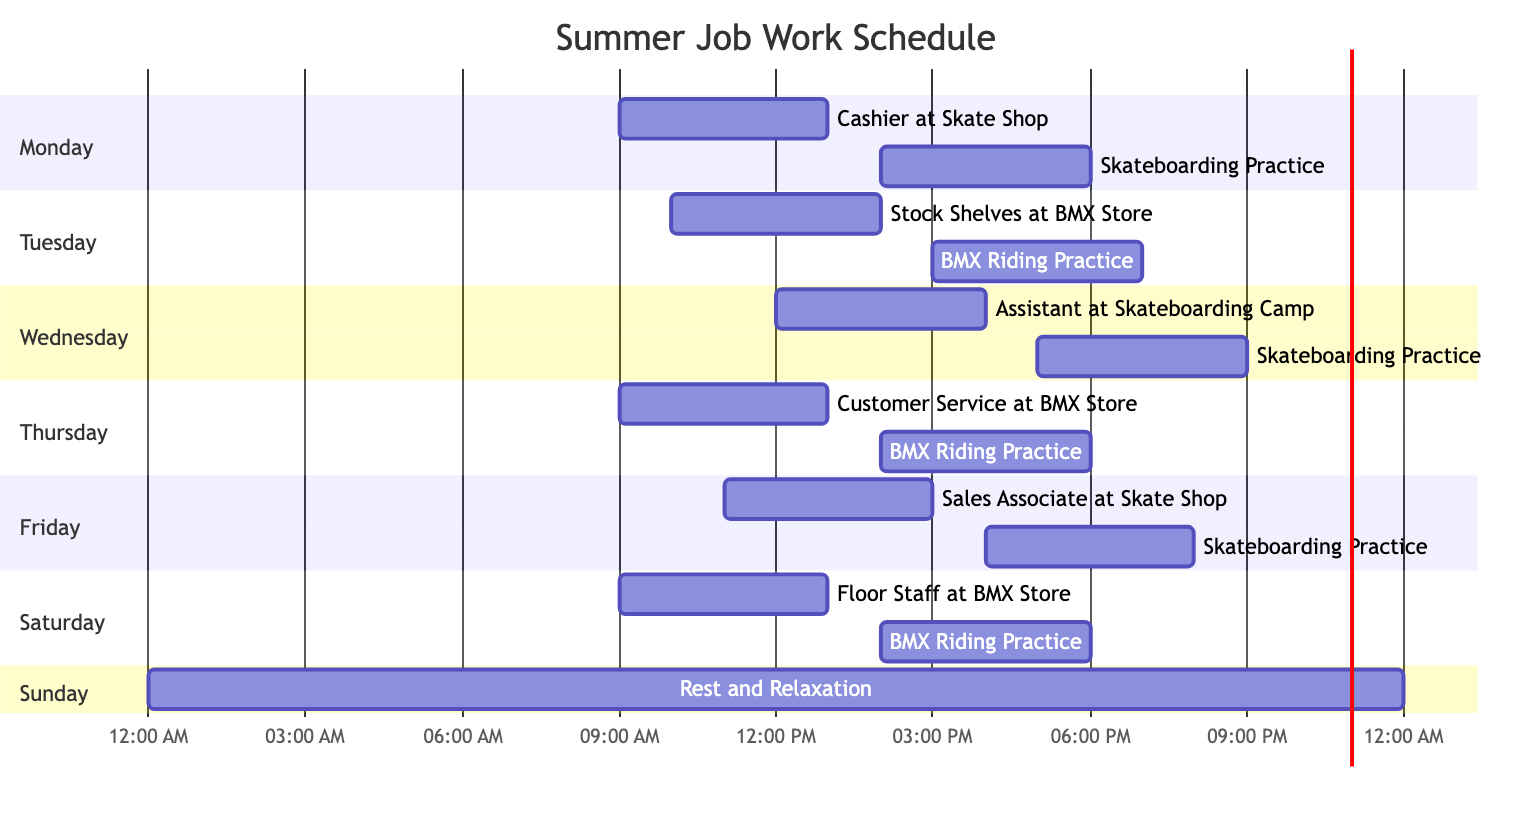What is the first activity on Monday? The diagram shows the schedule for Monday starting with the "Cashier at Skate Shop" shift scheduled at 09:00. This is the first activity listed under the Monday section.
Answer: Cashier at Skate Shop How many hours are dedicated to BMX Riding Practice? The schedule indicates BMX Riding Practice on Tuesday and Thursday for 4 hours each day, which totals to 8 hours across the week.
Answer: 8 hours What time does Skateboarding Practice start on Friday? The diagram indicates that Skateboarding Practice on Friday starts at 16:00, which is the scheduled start time listed under that day.
Answer: 16:00 Which day has a full 24-hour schedule for Rest and Relaxation? According to the diagram, Sunday is dedicated entirely to Rest and Relaxation, with a full 24-hour schedule indicated in that section.
Answer: Sunday On which day is the Assistant at Skateboarding Camp working? The schedule specifies that the Assistant at Skateboarding Camp works on Wednesday, starting at 12:00 for 4 hours. This is the only mention of this job in the entire diagram.
Answer: Wednesday If someone wants to practice Skateboarding immediately after their work shifts, which day can they do it right after? On Monday, after working as a Cashier at the Skate Shop from 09:00 to 13:00, they can practice Skateboarding from 14:00 to 18:00, making it possible to practice immediately after work.
Answer: Monday What is the latest start time for a work shift during the week? The latest start time for a work shift is on Friday, with the Sales Associate at Skate Shop starting at 11:00. All other shifts start earlier than this time.
Answer: 11:00 